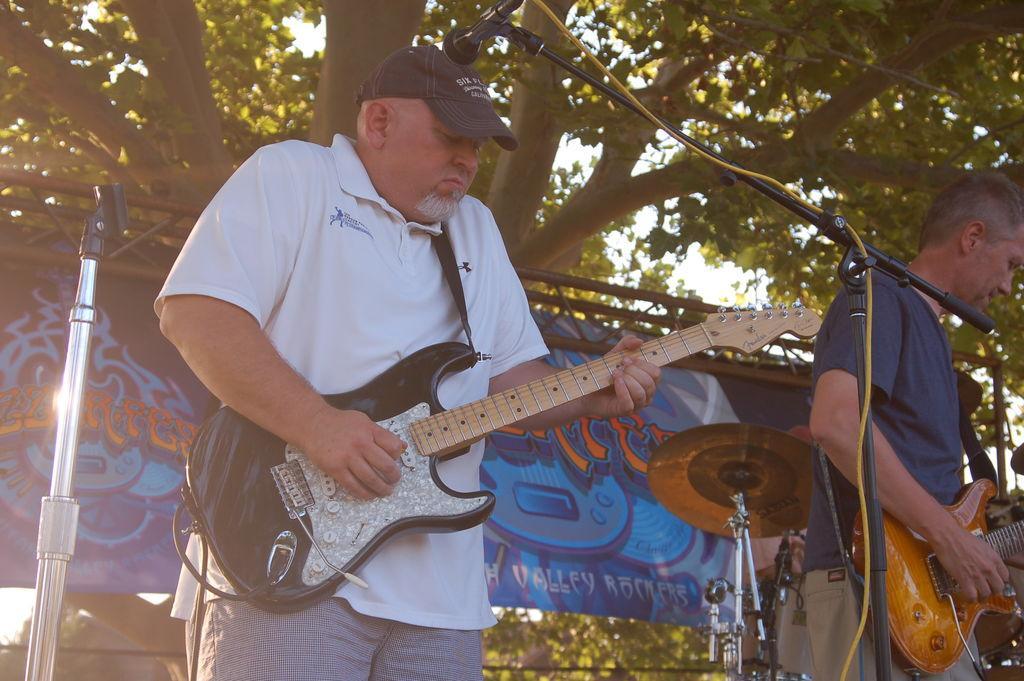Could you give a brief overview of what you see in this image? In this image there is a man standing and playing guitar , another man standing and playing guitar, and at the background there is banner, cymbal stand , tree, cables. 